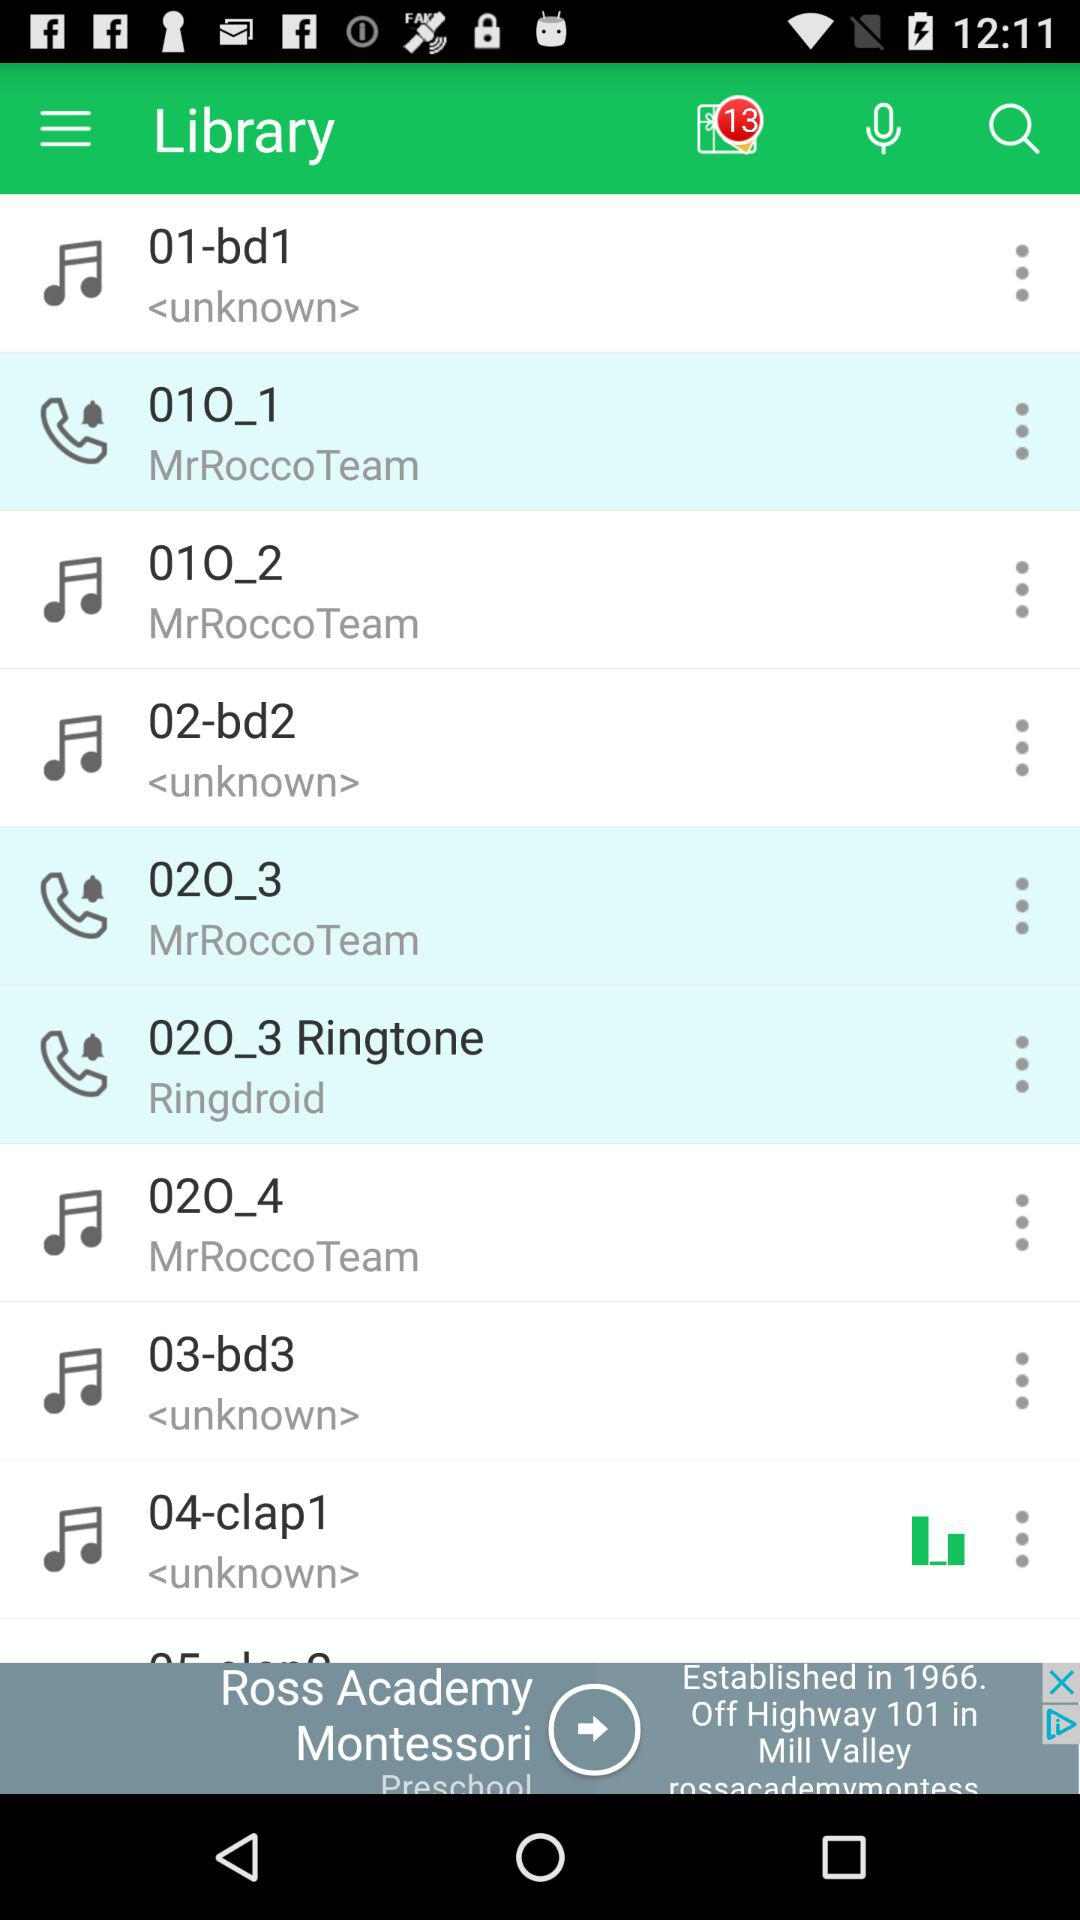Which audio is playing there on the screen? The audio that is playing there on the screen is "04-clap1". 